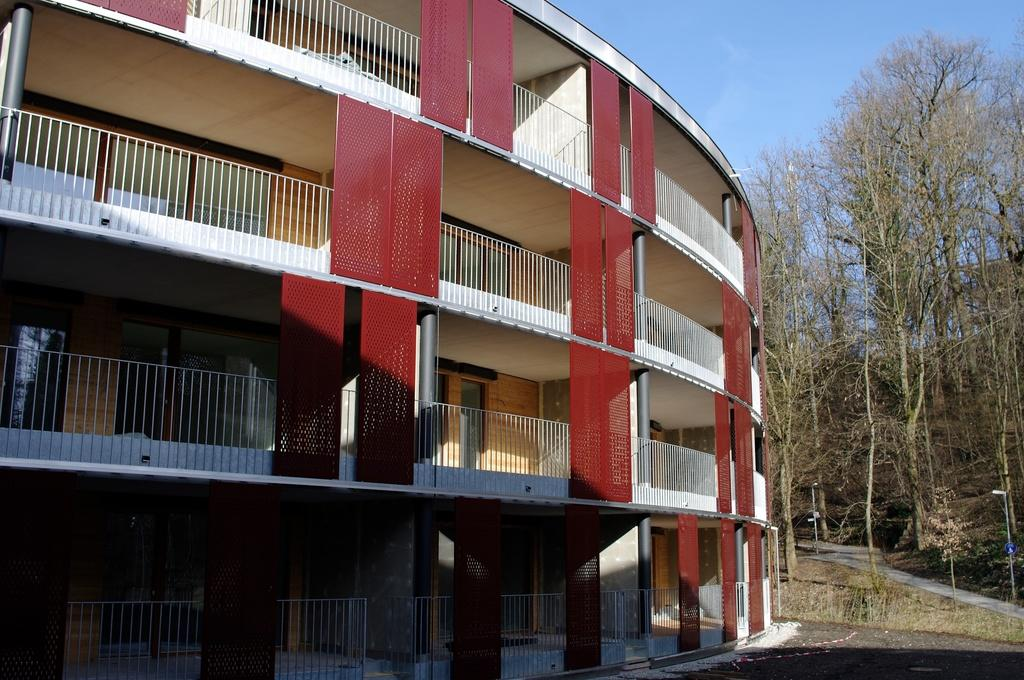What type of structure is depicted in the image? The image contains a building with pillars. What material is used for the grills on the building? The building has iron grills. What type of vegetation can be seen in the image? There are trees in the image. Can you describe the pathway in the image? The image appears to show a pathway. What is visible in the background of the image? The sky is visible in the image. What type of grape is being used to decorate the building in the image? There is no grape present in the image, and therefore no such decoration can be observed. How is the honey being used to maintain the iron grills in the image? There is no honey present in the image, and the iron grills do not require maintenance in the depicted scene. 